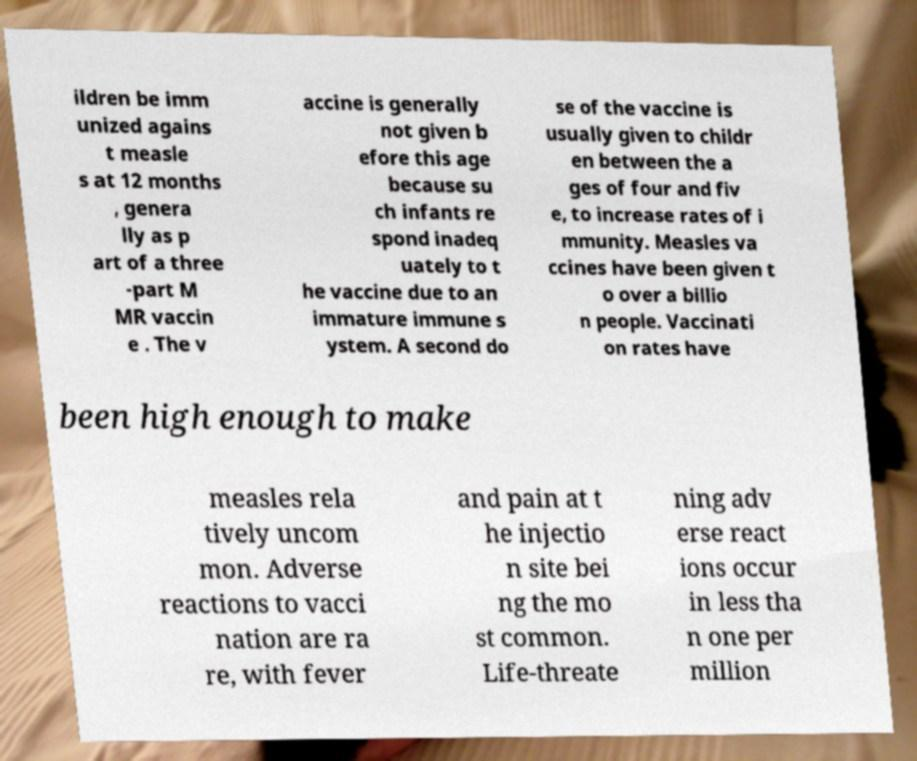Please read and relay the text visible in this image. What does it say? ildren be imm unized agains t measle s at 12 months , genera lly as p art of a three -part M MR vaccin e . The v accine is generally not given b efore this age because su ch infants re spond inadeq uately to t he vaccine due to an immature immune s ystem. A second do se of the vaccine is usually given to childr en between the a ges of four and fiv e, to increase rates of i mmunity. Measles va ccines have been given t o over a billio n people. Vaccinati on rates have been high enough to make measles rela tively uncom mon. Adverse reactions to vacci nation are ra re, with fever and pain at t he injectio n site bei ng the mo st common. Life-threate ning adv erse react ions occur in less tha n one per million 